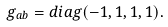Convert formula to latex. <formula><loc_0><loc_0><loc_500><loc_500>g _ { a b } = d i a g ( - 1 , 1 , 1 , 1 ) .</formula> 